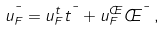<formula> <loc_0><loc_0><loc_500><loc_500>u _ { F } ^ { \mu } = u _ { F } ^ { t } t ^ { \mu } + u _ { F } ^ { \phi } \phi ^ { \mu } \, ,</formula> 